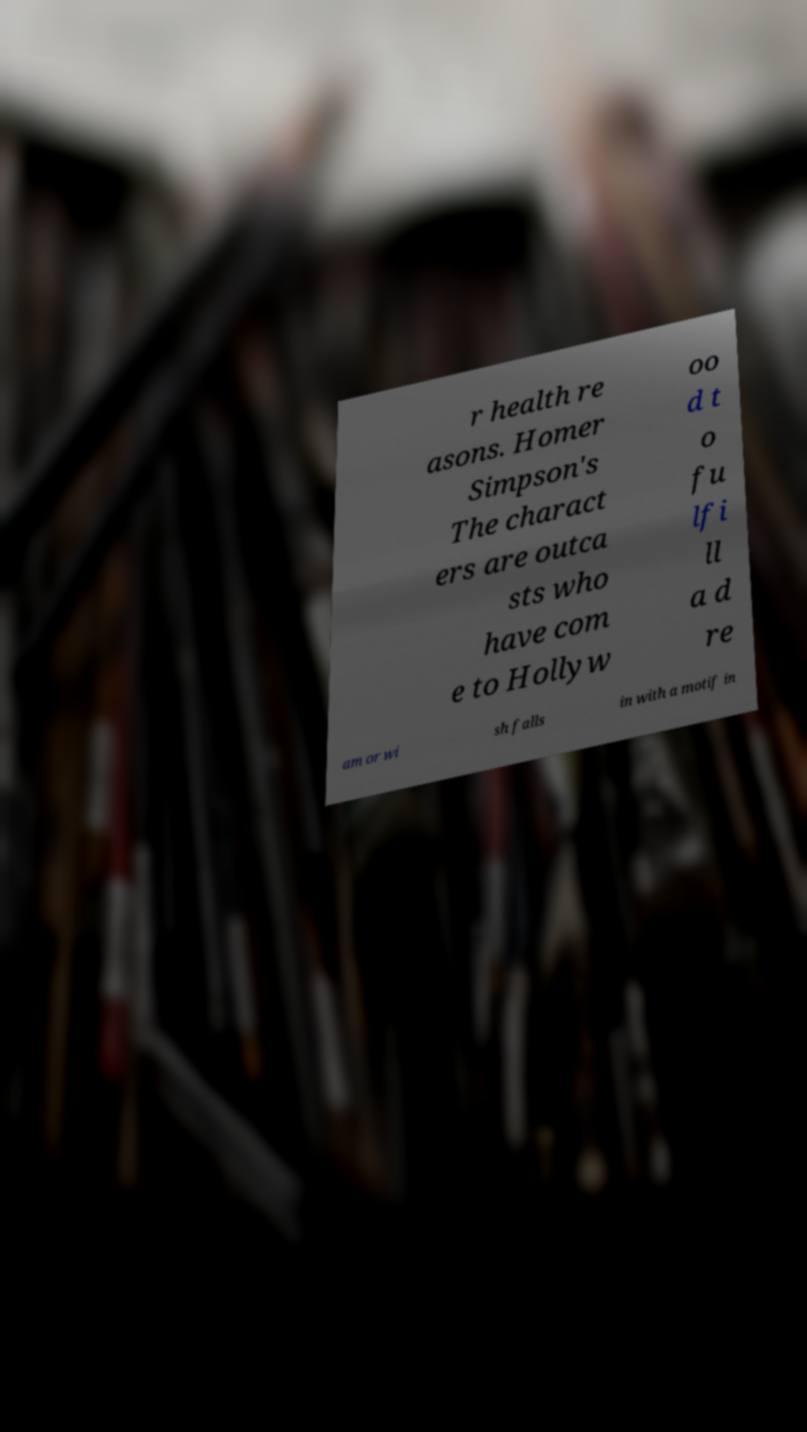Could you assist in decoding the text presented in this image and type it out clearly? r health re asons. Homer Simpson's The charact ers are outca sts who have com e to Hollyw oo d t o fu lfi ll a d re am or wi sh falls in with a motif in 